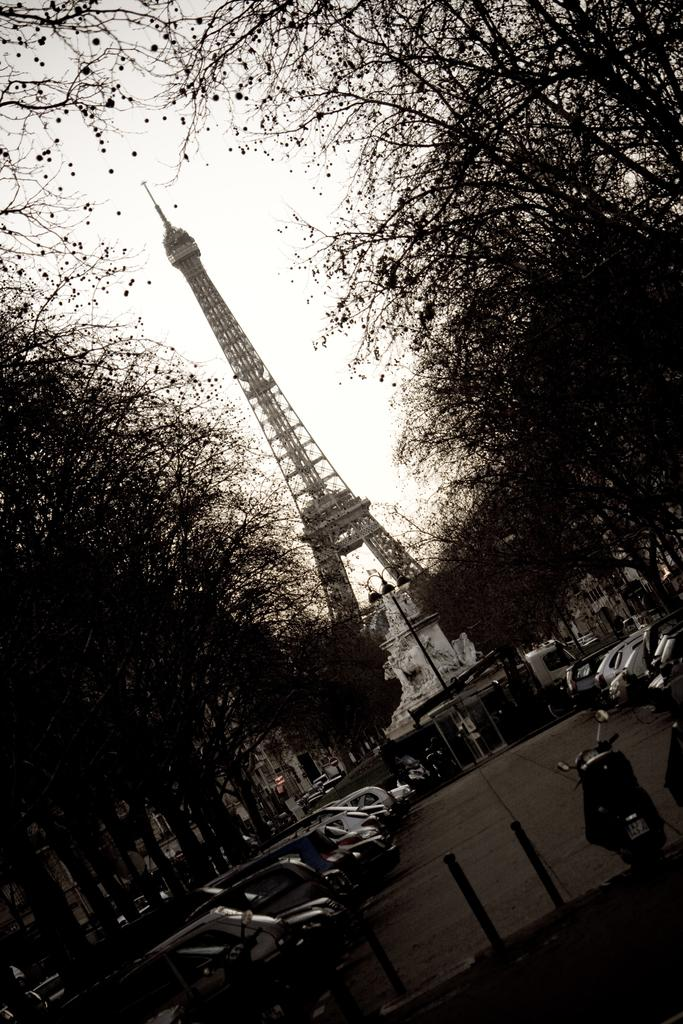What famous landmark can be seen in the image? There is an Eiffel tower in the image. What else is present in the image besides the Eiffel tower? There are vehicles and trees visible in the image. What can be seen in the sky in the image? The sky is visible in the image. Can you read the letter that the family is holding in the image? There is no family or letter present in the image; it features the Eiffel tower, vehicles, trees, and the sky. 